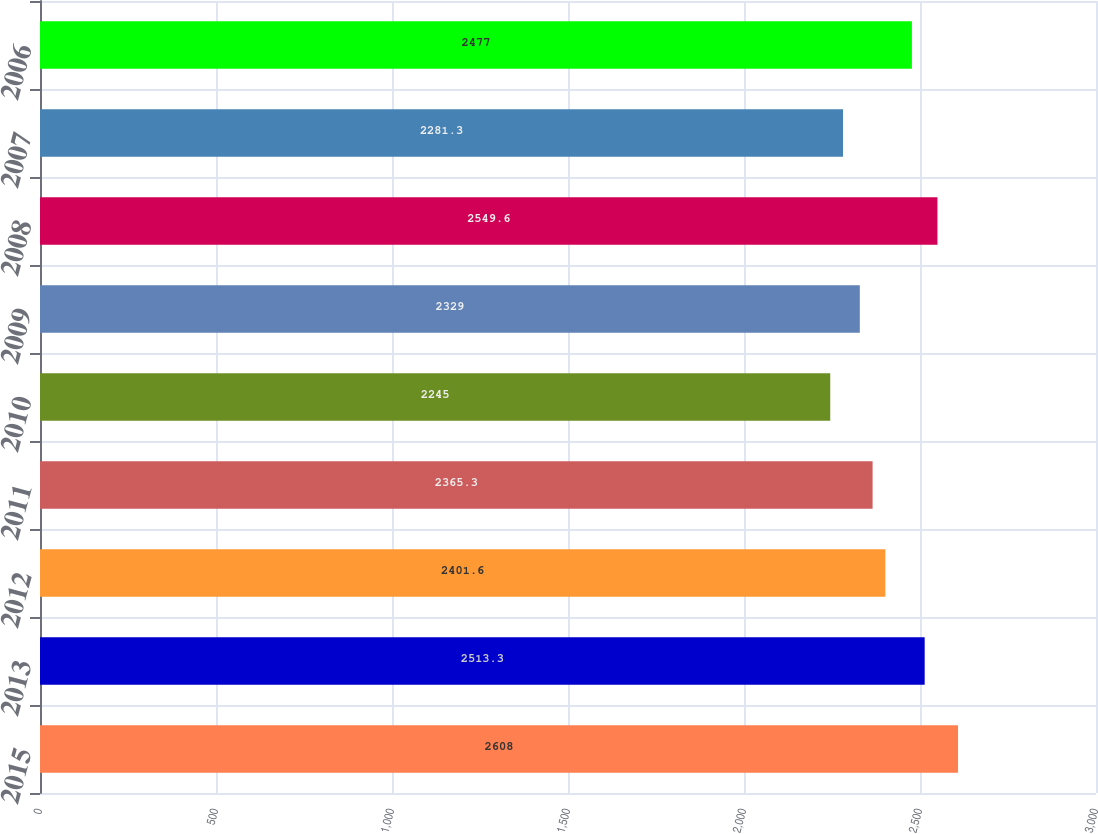Convert chart. <chart><loc_0><loc_0><loc_500><loc_500><bar_chart><fcel>2015<fcel>2013<fcel>2012<fcel>2011<fcel>2010<fcel>2009<fcel>2008<fcel>2007<fcel>2006<nl><fcel>2608<fcel>2513.3<fcel>2401.6<fcel>2365.3<fcel>2245<fcel>2329<fcel>2549.6<fcel>2281.3<fcel>2477<nl></chart> 